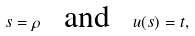Convert formula to latex. <formula><loc_0><loc_0><loc_500><loc_500>s = \rho \text { \ \ and \ \ } u ( s ) = t ,</formula> 